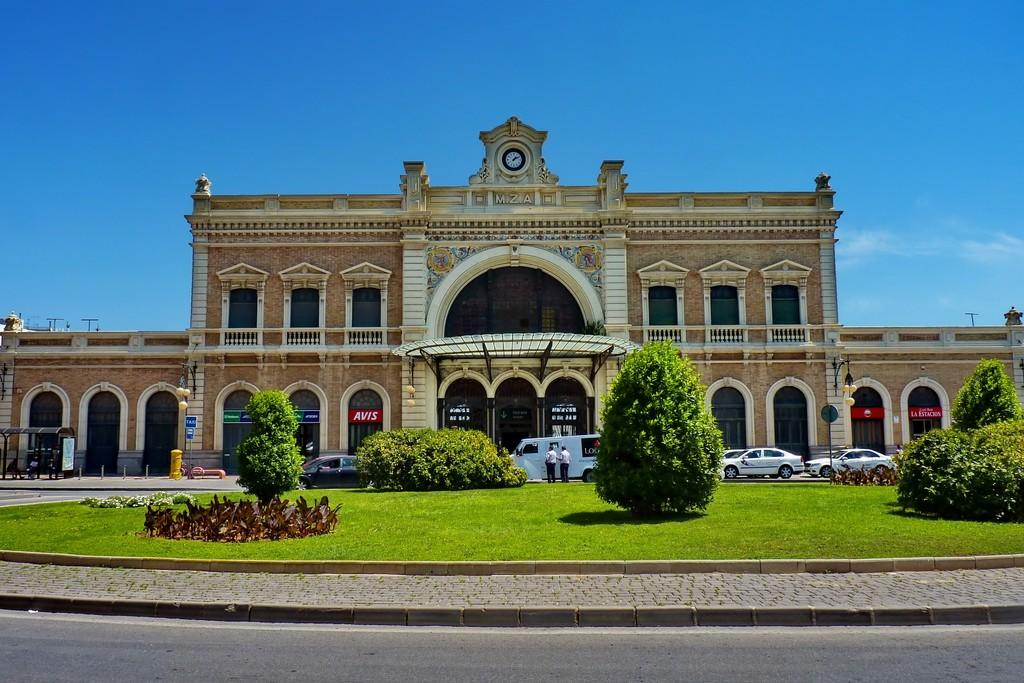<image>
Summarize the visual content of the image. A building with many shops in it, including an Avis store. 